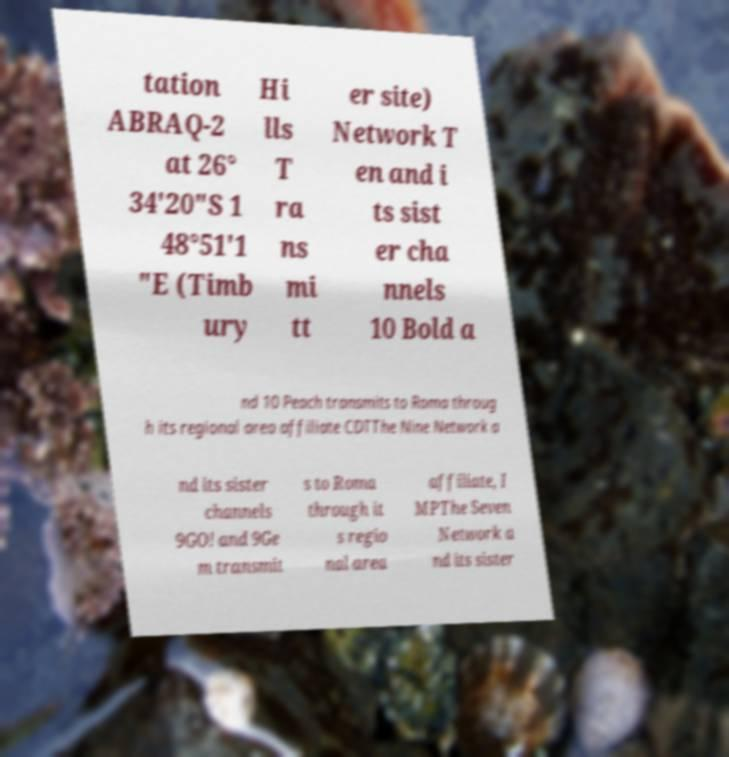I need the written content from this picture converted into text. Can you do that? tation ABRAQ-2 at 26° 34′20″S 1 48°51′1 ″E (Timb ury Hi lls T ra ns mi tt er site) Network T en and i ts sist er cha nnels 10 Bold a nd 10 Peach transmits to Roma throug h its regional area affiliate CDTThe Nine Network a nd its sister channels 9GO! and 9Ge m transmit s to Roma through it s regio nal area affiliate, I MPThe Seven Network a nd its sister 